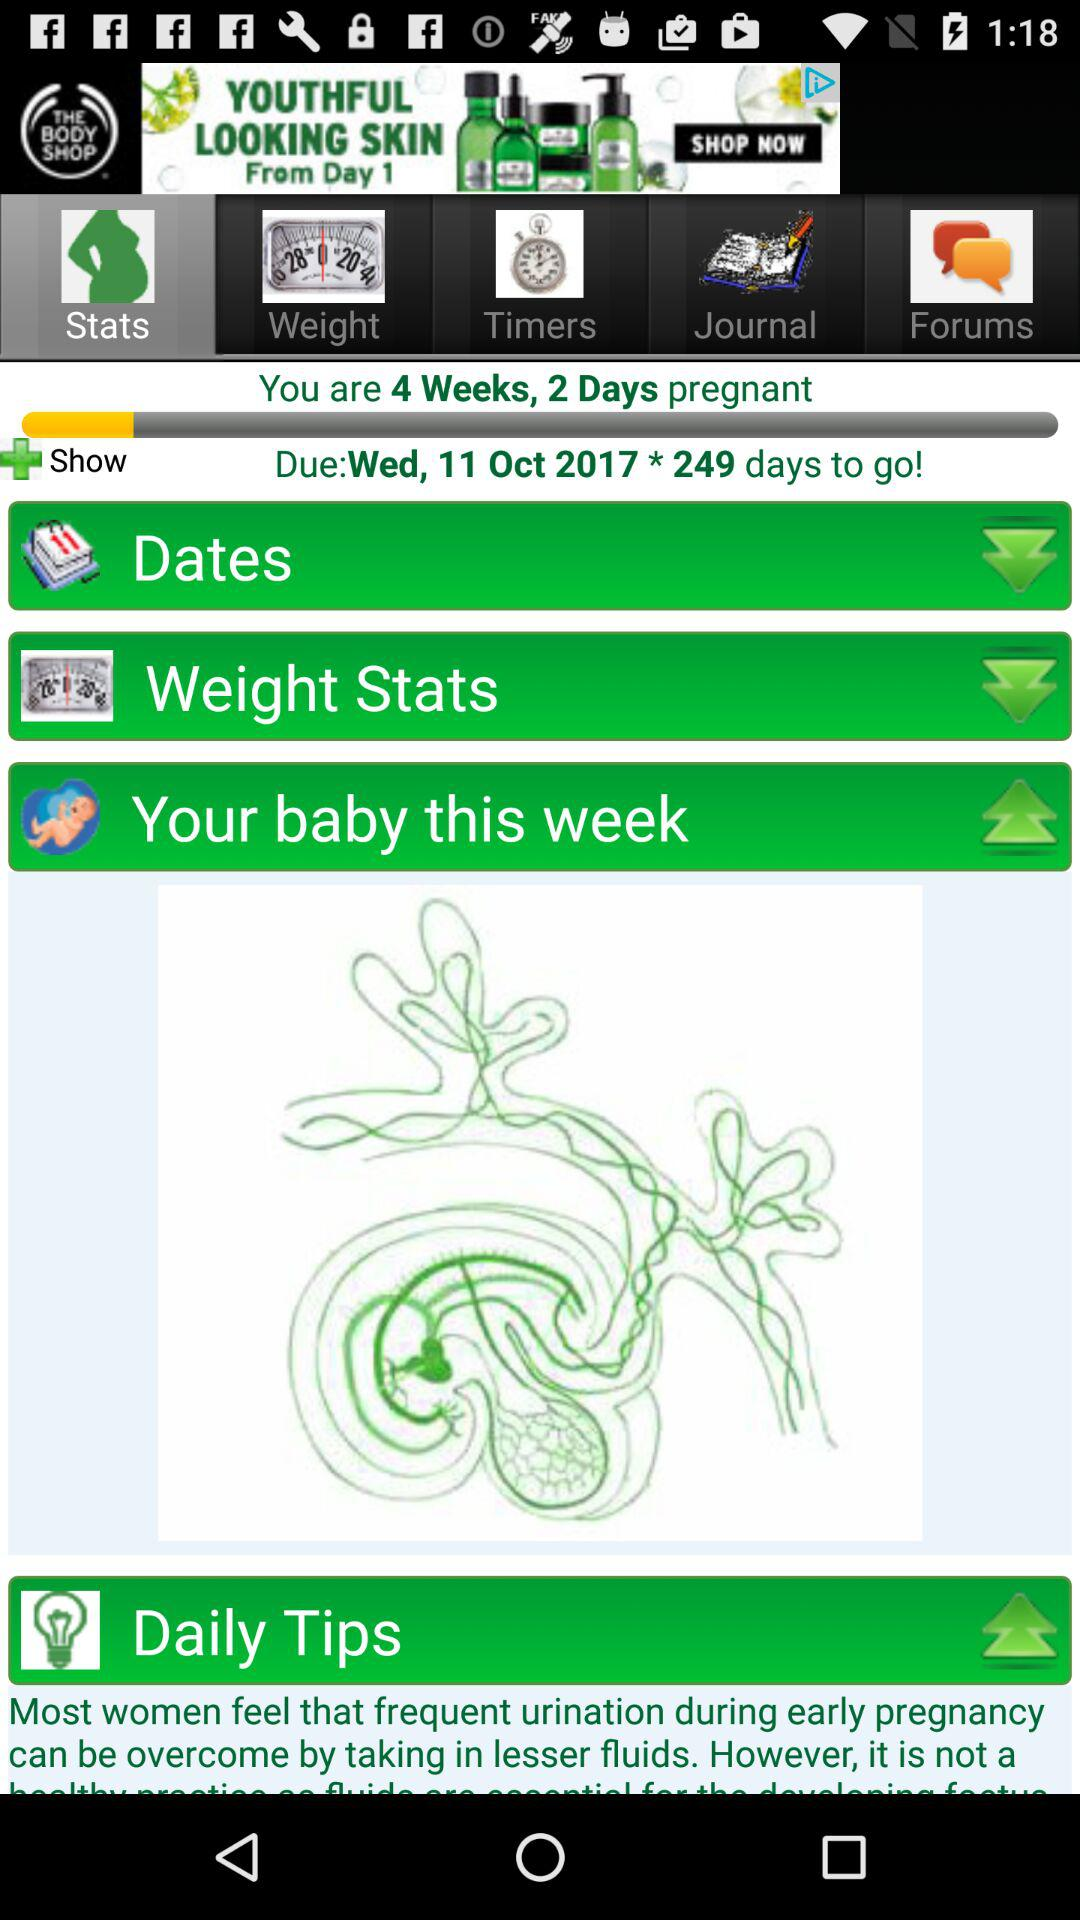What is the date? The date is Wednesday, October 11, 2017. 